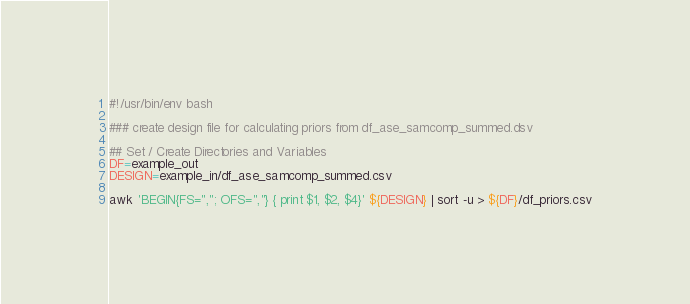Convert code to text. <code><loc_0><loc_0><loc_500><loc_500><_Bash_>#!/usr/bin/env bash

### create design file for calculating priors from df_ase_samcomp_summed.dsv 

## Set / Create Directories and Variables
DF=example_out
DESIGN=example_in/df_ase_samcomp_summed.csv

awk 'BEGIN{FS=","; OFS=","} { print $1, $2, $4}' ${DESIGN} | sort -u > ${DF}/df_priors.csv
</code> 